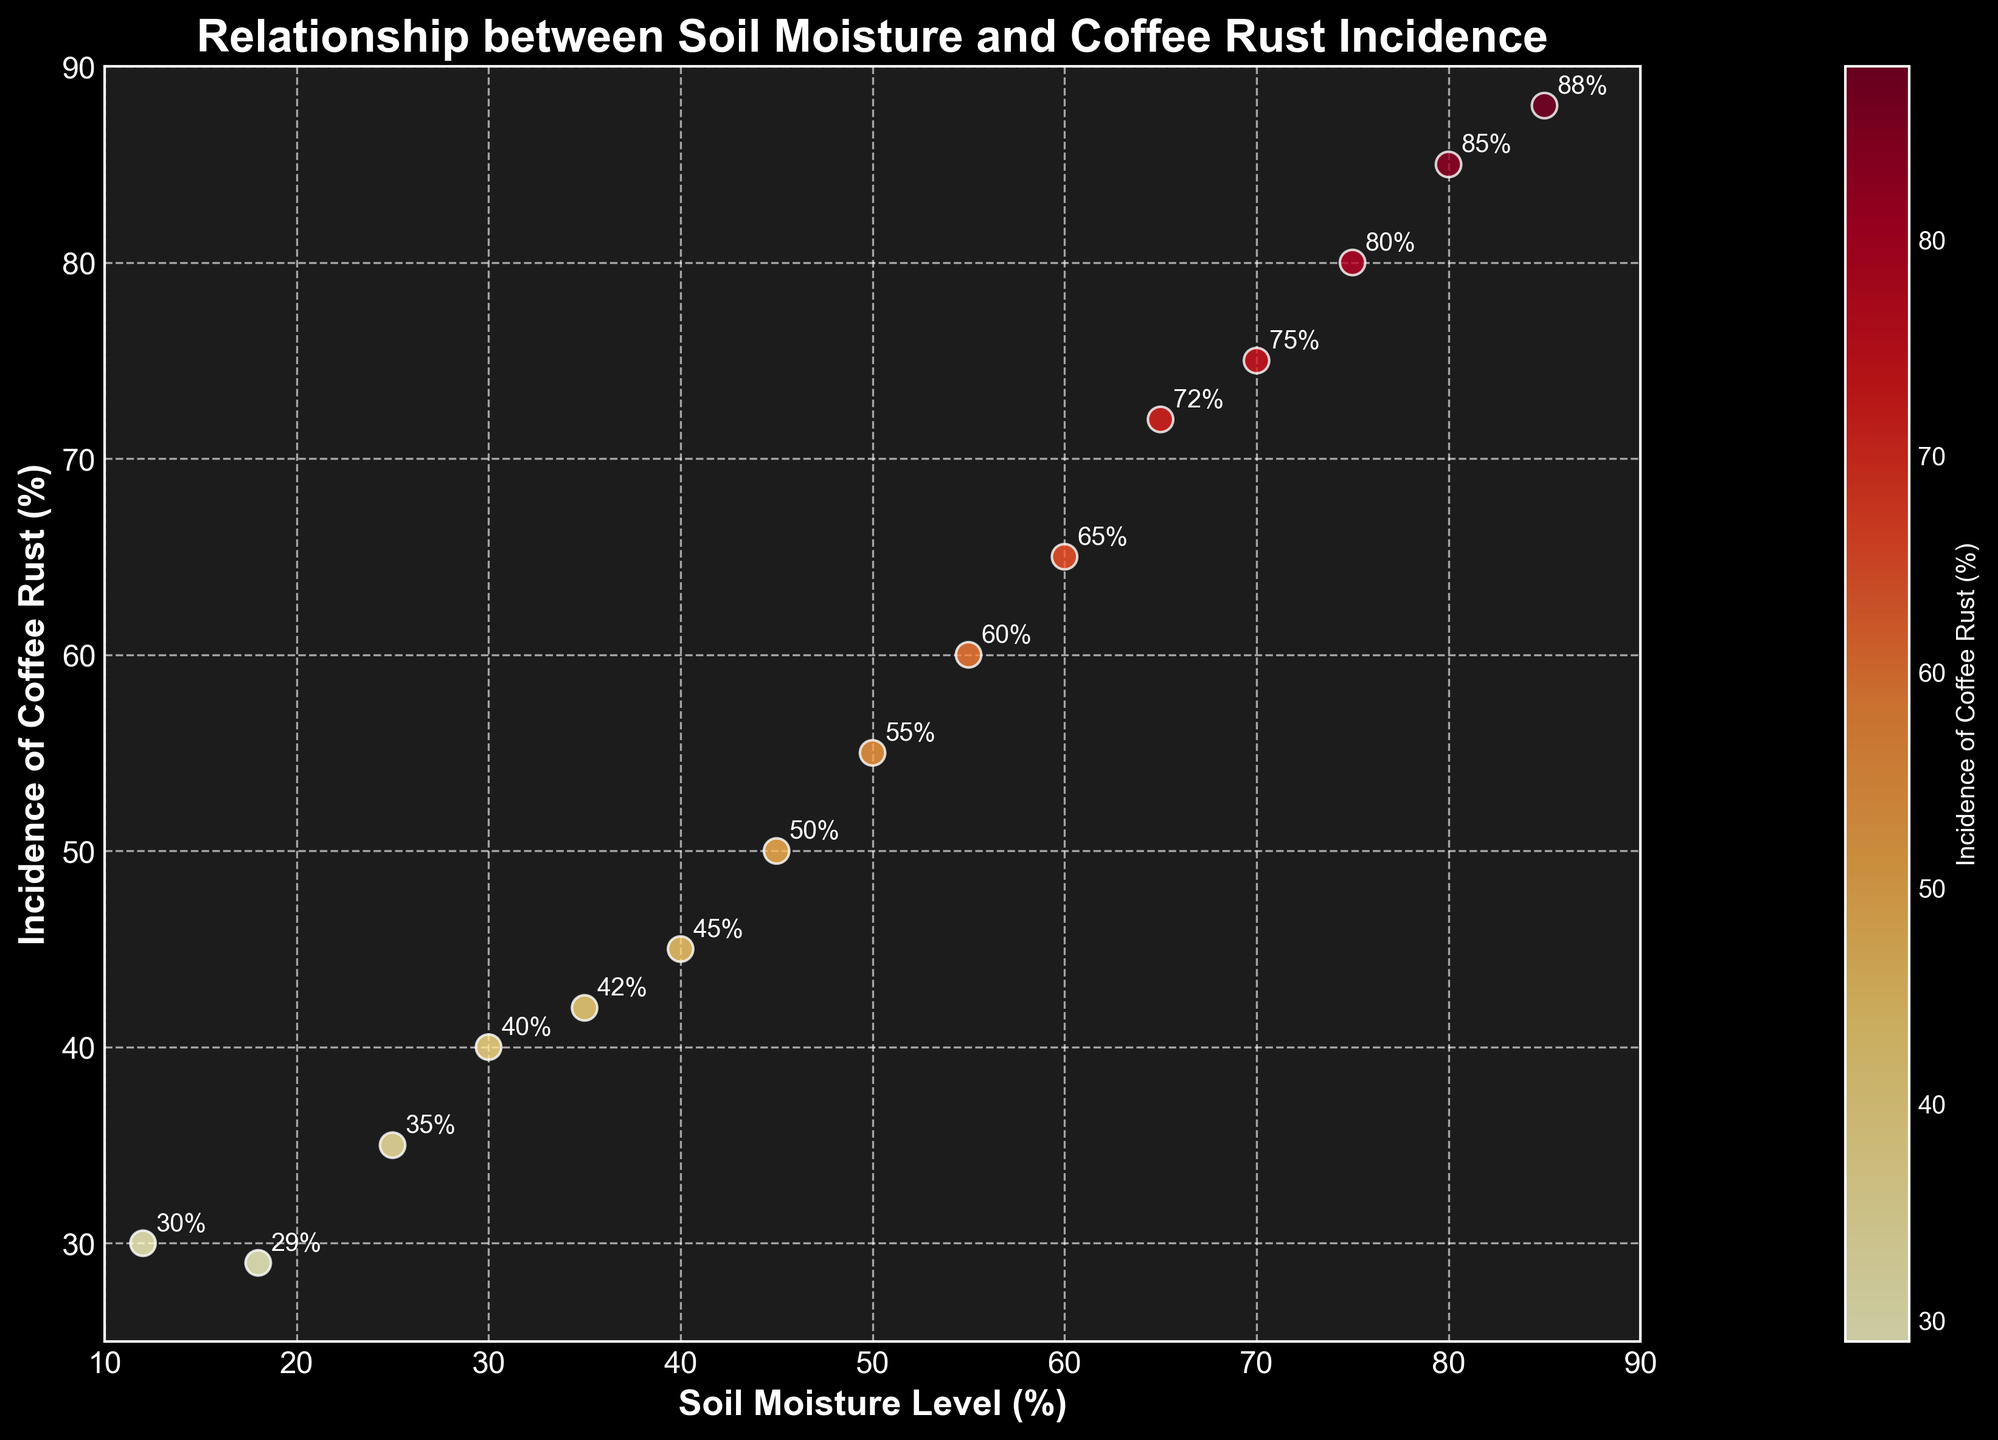What's the range of soil moisture levels represented in the plot? The figure has data points starting from 12% to 85% for soil moisture levels. The range is therefore calculated by subtracting the minimum value from the maximum value, which is 85% - 12%.
Answer: 73% What is the incidence of Coffee Rust at 50% soil moisture level? By locating the data point corresponding to 50% soil moisture on the x-axis, we see that the incidence of Coffee Rust at this level is 55%.
Answer: 55% How many data points are shown in the plot? There are 15 pairs of values (soil moisture level, incidence of Coffee Rust) provided, and each pair is represented as a single data point in the scatter plot.
Answer: 15 At which soil moisture level is the incidence of Coffee Rust the highest? Locate the highest y-value on the scatter plot, which represents the highest incidence of Coffee Rust. The corresponding x-value (soil moisture level) is 85%.
Answer: 85% What can you say about the general relationship between soil moisture levels and incidence of Coffee Rust? By observing the trend in the scatter plot, where the points generally increase in y-value (incidence) as the x-value (soil moisture) increases, we can infer that there is a positive correlation between soil moisture levels and incidence of Coffee Rust.
Answer: Positive correlation Compare the incidence of Coffee Rust at 25% and 75% soil moisture levels. Find the y-values corresponding to 25% and 75% soil moisture levels on the scatter plot. The incidence of Coffee Rust at 25% is 35%, and at 75%, it is 80%.
Answer: 25%: 35%, 75%: 80% Is there any soil moisture level where the incidence of Coffee Rust is below 30%? To find out, look for y-values that are below 30 on the scatter plot. The incidence of Coffee Rust is below 30% only at the 12% soil moisture level.
Answer: Yes, at 12% What color trend can you observe in the points as soil moisture and incidence of Coffee Rust increase? The scatter plot uses colors from the 'YlOrRd' (Yellow-Orange-Red) color map. As both soil moisture and incidence of Coffee Rust levels increase, the color of the points transitions from yellow to red.
Answer: Yellow to Red 